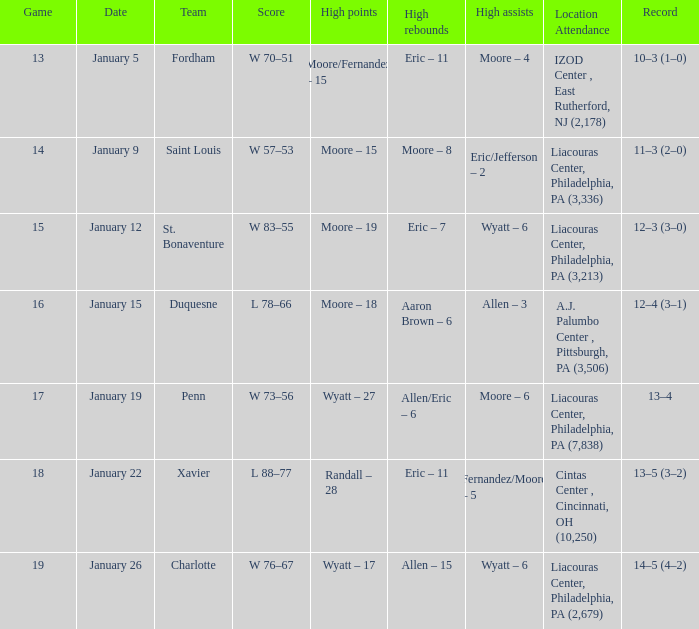Who achieved the greatest number of assists and what was their count on january 5? Moore – 4. 